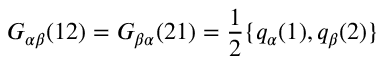<formula> <loc_0><loc_0><loc_500><loc_500>G _ { \alpha \beta } ( 1 2 ) = G _ { \beta \alpha } ( 2 1 ) = \frac { 1 } { 2 } \{ q _ { \alpha } ( 1 ) , q _ { \beta } ( 2 ) \}</formula> 